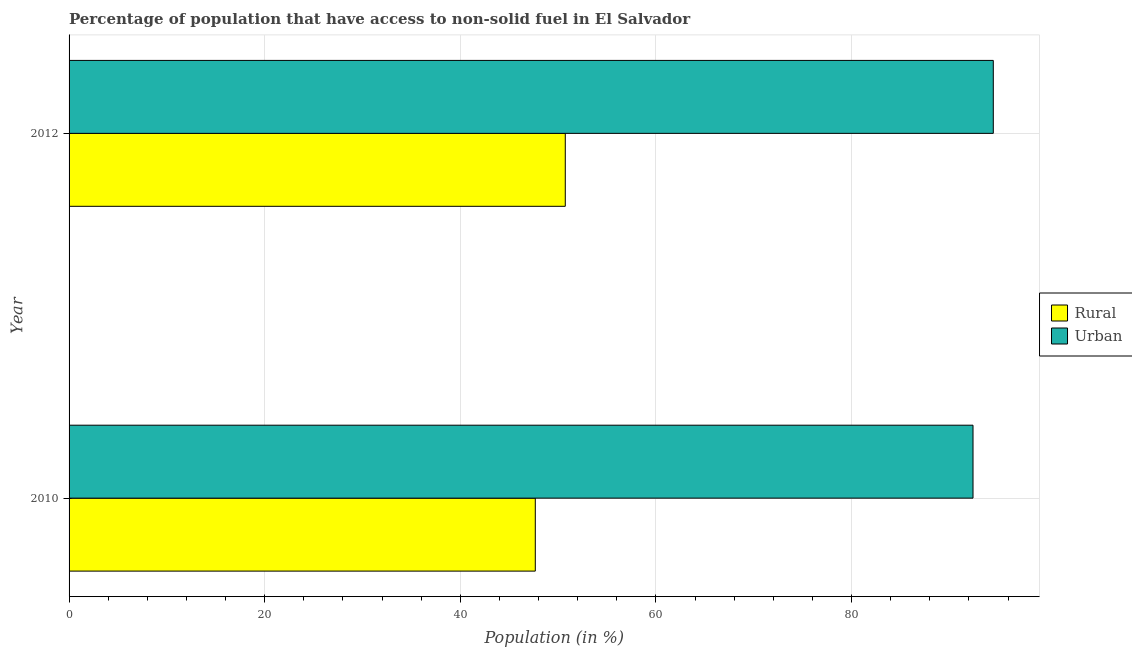How many different coloured bars are there?
Offer a terse response. 2. Are the number of bars per tick equal to the number of legend labels?
Provide a succinct answer. Yes. How many bars are there on the 1st tick from the top?
Give a very brief answer. 2. How many bars are there on the 1st tick from the bottom?
Your answer should be very brief. 2. What is the label of the 2nd group of bars from the top?
Keep it short and to the point. 2010. What is the urban population in 2010?
Your answer should be compact. 92.41. Across all years, what is the maximum urban population?
Your response must be concise. 94.49. Across all years, what is the minimum rural population?
Your answer should be very brief. 47.66. In which year was the urban population minimum?
Keep it short and to the point. 2010. What is the total rural population in the graph?
Provide a short and direct response. 98.39. What is the difference between the urban population in 2010 and that in 2012?
Your response must be concise. -2.07. What is the difference between the urban population in 2010 and the rural population in 2012?
Provide a succinct answer. 41.68. What is the average rural population per year?
Make the answer very short. 49.2. In the year 2012, what is the difference between the urban population and rural population?
Your response must be concise. 43.76. What is the ratio of the rural population in 2010 to that in 2012?
Make the answer very short. 0.94. Is the rural population in 2010 less than that in 2012?
Your answer should be compact. Yes. What does the 1st bar from the top in 2010 represents?
Your answer should be very brief. Urban. What does the 1st bar from the bottom in 2010 represents?
Make the answer very short. Rural. How many bars are there?
Offer a very short reply. 4. What is the difference between two consecutive major ticks on the X-axis?
Keep it short and to the point. 20. Are the values on the major ticks of X-axis written in scientific E-notation?
Offer a very short reply. No. Does the graph contain any zero values?
Keep it short and to the point. No. How many legend labels are there?
Make the answer very short. 2. What is the title of the graph?
Your response must be concise. Percentage of population that have access to non-solid fuel in El Salvador. Does "Taxes on exports" appear as one of the legend labels in the graph?
Keep it short and to the point. No. What is the label or title of the X-axis?
Keep it short and to the point. Population (in %). What is the label or title of the Y-axis?
Ensure brevity in your answer.  Year. What is the Population (in %) in Rural in 2010?
Provide a short and direct response. 47.66. What is the Population (in %) in Urban in 2010?
Offer a very short reply. 92.41. What is the Population (in %) in Rural in 2012?
Your answer should be very brief. 50.73. What is the Population (in %) of Urban in 2012?
Give a very brief answer. 94.49. Across all years, what is the maximum Population (in %) in Rural?
Your answer should be very brief. 50.73. Across all years, what is the maximum Population (in %) in Urban?
Your answer should be compact. 94.49. Across all years, what is the minimum Population (in %) in Rural?
Offer a terse response. 47.66. Across all years, what is the minimum Population (in %) in Urban?
Your answer should be very brief. 92.41. What is the total Population (in %) of Rural in the graph?
Your response must be concise. 98.39. What is the total Population (in %) of Urban in the graph?
Keep it short and to the point. 186.9. What is the difference between the Population (in %) in Rural in 2010 and that in 2012?
Keep it short and to the point. -3.07. What is the difference between the Population (in %) in Urban in 2010 and that in 2012?
Your response must be concise. -2.07. What is the difference between the Population (in %) in Rural in 2010 and the Population (in %) in Urban in 2012?
Your answer should be compact. -46.82. What is the average Population (in %) of Rural per year?
Keep it short and to the point. 49.2. What is the average Population (in %) in Urban per year?
Make the answer very short. 93.45. In the year 2010, what is the difference between the Population (in %) in Rural and Population (in %) in Urban?
Keep it short and to the point. -44.75. In the year 2012, what is the difference between the Population (in %) of Rural and Population (in %) of Urban?
Your answer should be very brief. -43.76. What is the ratio of the Population (in %) in Rural in 2010 to that in 2012?
Your answer should be very brief. 0.94. What is the ratio of the Population (in %) of Urban in 2010 to that in 2012?
Ensure brevity in your answer.  0.98. What is the difference between the highest and the second highest Population (in %) in Rural?
Make the answer very short. 3.07. What is the difference between the highest and the second highest Population (in %) of Urban?
Offer a terse response. 2.07. What is the difference between the highest and the lowest Population (in %) in Rural?
Offer a terse response. 3.07. What is the difference between the highest and the lowest Population (in %) in Urban?
Your response must be concise. 2.07. 